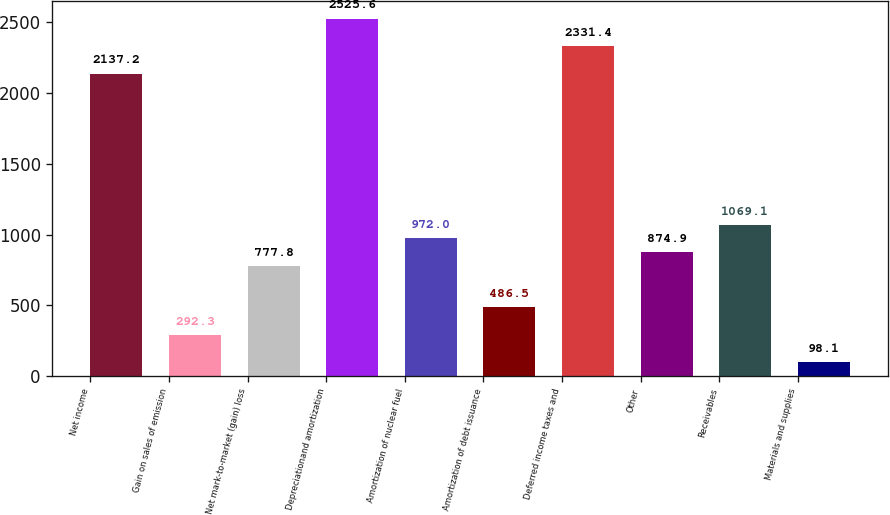Convert chart to OTSL. <chart><loc_0><loc_0><loc_500><loc_500><bar_chart><fcel>Net income<fcel>Gain on sales of emission<fcel>Net mark-to-market (gain) loss<fcel>Depreciationand amortization<fcel>Amortization of nuclear fuel<fcel>Amortization of debt issuance<fcel>Deferred income taxes and<fcel>Other<fcel>Receivables<fcel>Materials and supplies<nl><fcel>2137.2<fcel>292.3<fcel>777.8<fcel>2525.6<fcel>972<fcel>486.5<fcel>2331.4<fcel>874.9<fcel>1069.1<fcel>98.1<nl></chart> 